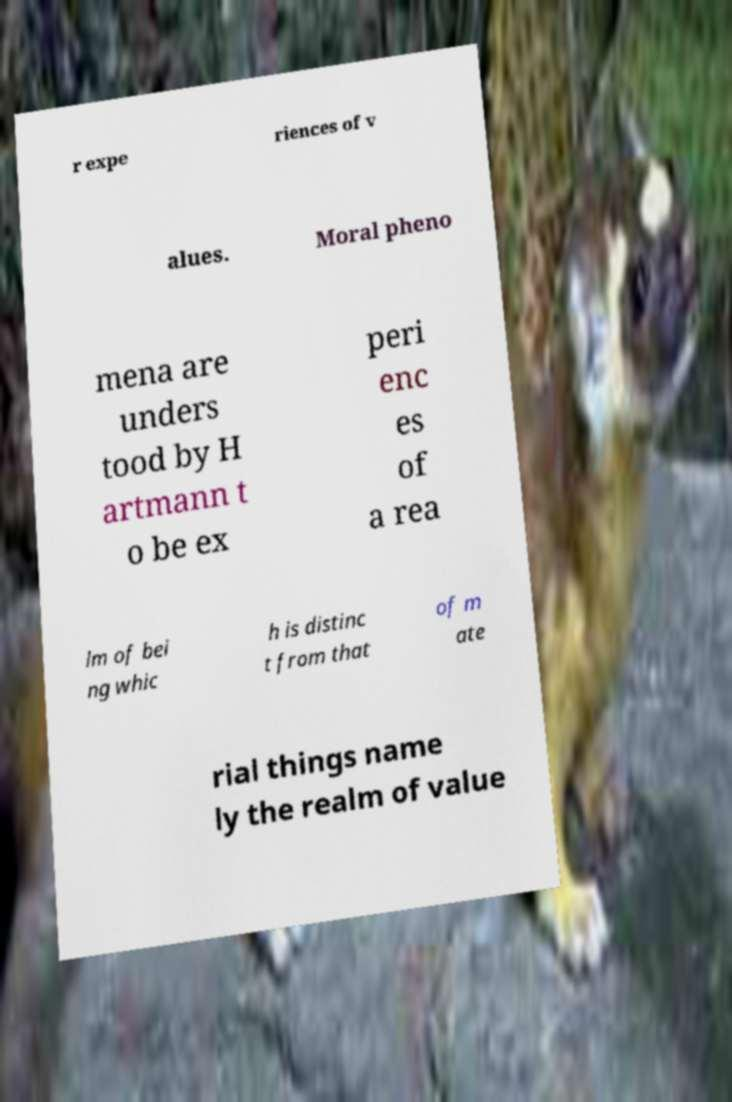There's text embedded in this image that I need extracted. Can you transcribe it verbatim? r expe riences of v alues. Moral pheno mena are unders tood by H artmann t o be ex peri enc es of a rea lm of bei ng whic h is distinc t from that of m ate rial things name ly the realm of value 